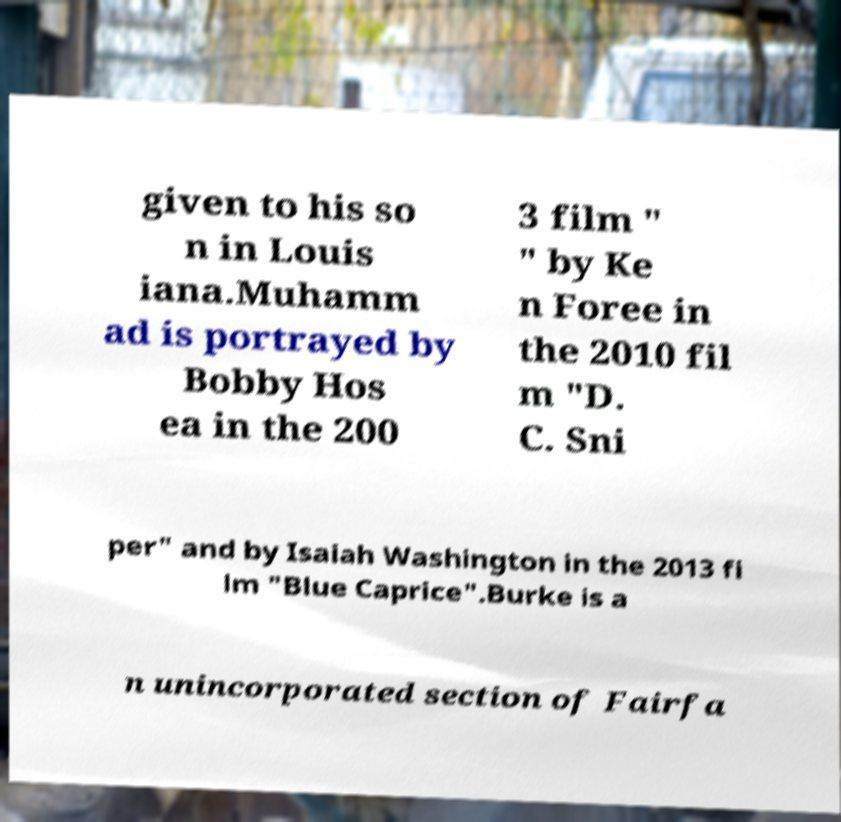Can you read and provide the text displayed in the image?This photo seems to have some interesting text. Can you extract and type it out for me? given to his so n in Louis iana.Muhamm ad is portrayed by Bobby Hos ea in the 200 3 film " " by Ke n Foree in the 2010 fil m "D. C. Sni per" and by Isaiah Washington in the 2013 fi lm "Blue Caprice".Burke is a n unincorporated section of Fairfa 